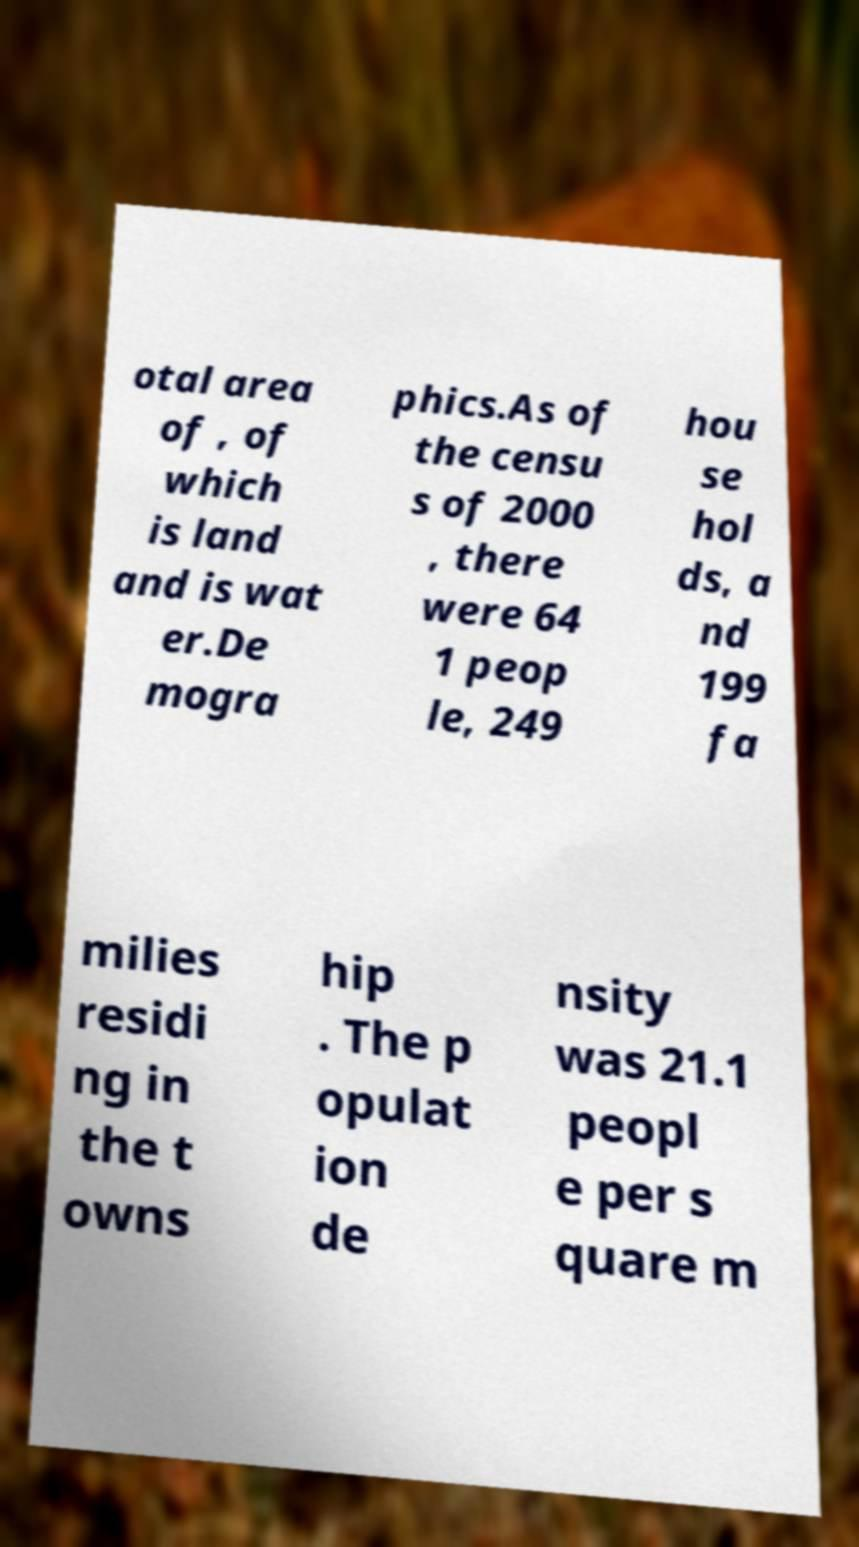Can you accurately transcribe the text from the provided image for me? otal area of , of which is land and is wat er.De mogra phics.As of the censu s of 2000 , there were 64 1 peop le, 249 hou se hol ds, a nd 199 fa milies residi ng in the t owns hip . The p opulat ion de nsity was 21.1 peopl e per s quare m 